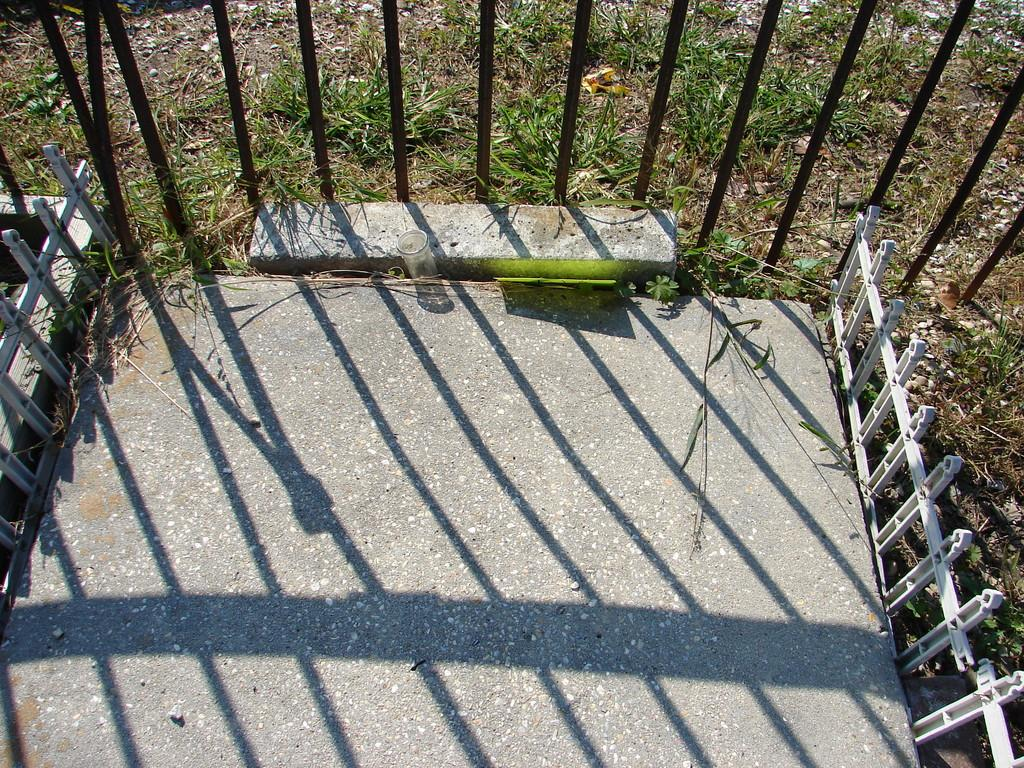What type of surface is visible in the image? There is a path in the image. What feature is present along the path? The path is partially covered with railing. What can be seen behind the railing on the path? There is grass on the path behind the railing. What type of juice is being served on the path in the image? There is no juice present in the image; it features a path with railing and grass. How many steps are visible on the path in the image? There are no steps visible on the path in the image; it only shows a path with railing and grass. 